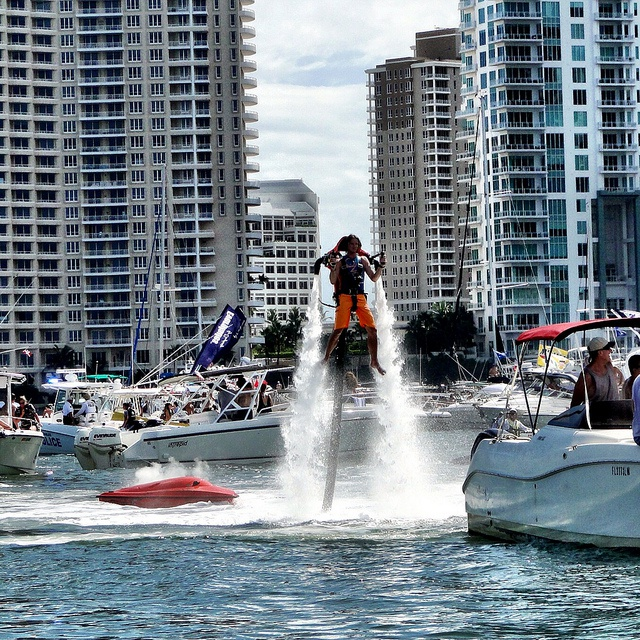Describe the objects in this image and their specific colors. I can see boat in gray and black tones, boat in gray, darkgray, and black tones, people in gray, black, lightgray, and maroon tones, boat in gray, black, darkgray, and lightgray tones, and boat in gray, lightgray, black, and darkgray tones in this image. 